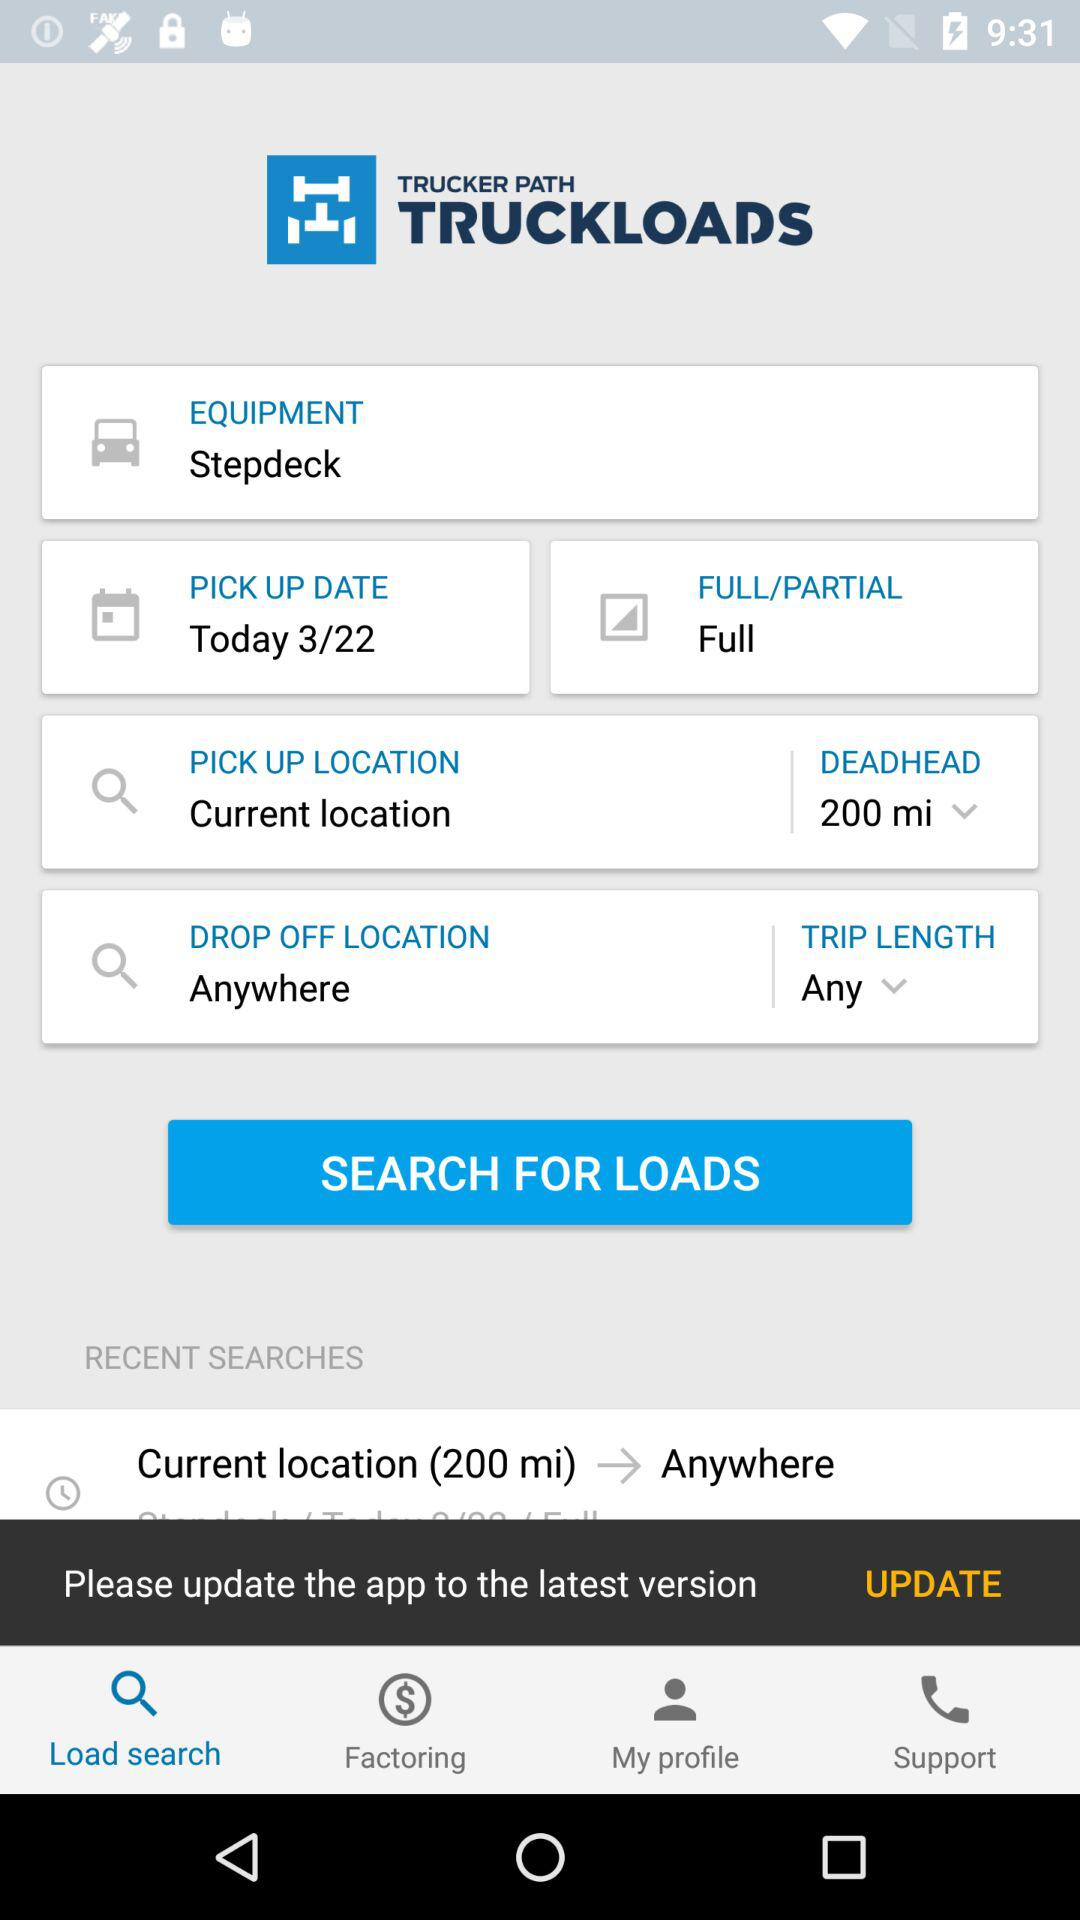How many days after today is the pick up date?
Answer the question using a single word or phrase. 0 